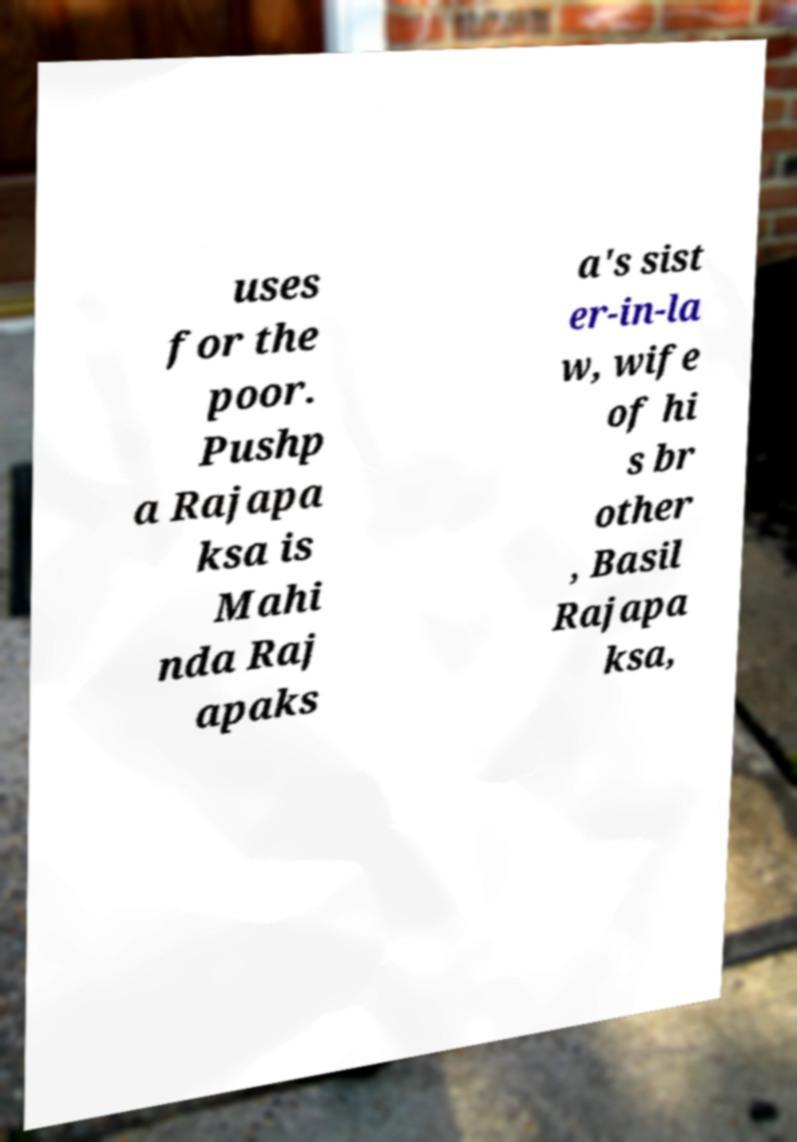I need the written content from this picture converted into text. Can you do that? uses for the poor. Pushp a Rajapa ksa is Mahi nda Raj apaks a's sist er-in-la w, wife of hi s br other , Basil Rajapa ksa, 